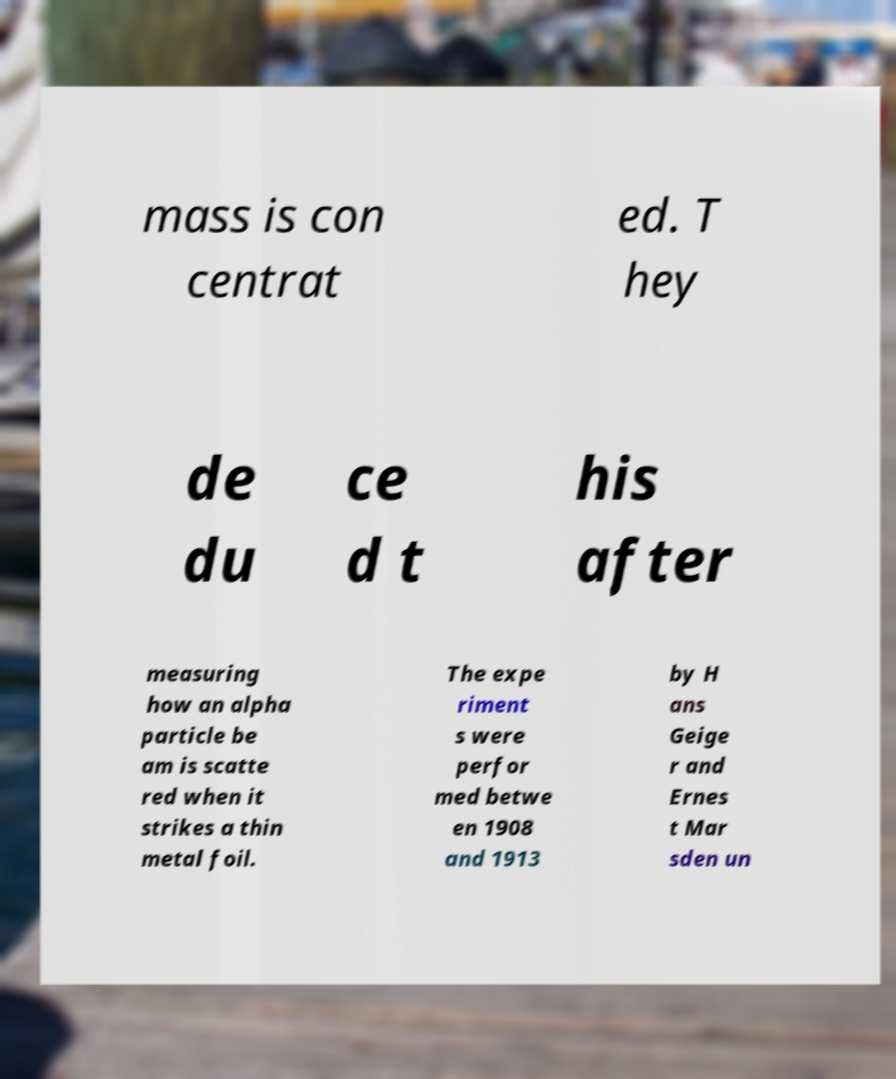Could you extract and type out the text from this image? mass is con centrat ed. T hey de du ce d t his after measuring how an alpha particle be am is scatte red when it strikes a thin metal foil. The expe riment s were perfor med betwe en 1908 and 1913 by H ans Geige r and Ernes t Mar sden un 